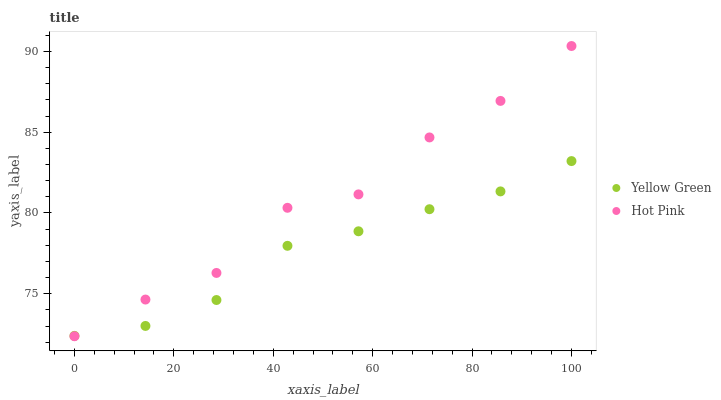Does Yellow Green have the minimum area under the curve?
Answer yes or no. Yes. Does Hot Pink have the maximum area under the curve?
Answer yes or no. Yes. Does Yellow Green have the maximum area under the curve?
Answer yes or no. No. Is Yellow Green the smoothest?
Answer yes or no. Yes. Is Hot Pink the roughest?
Answer yes or no. Yes. Is Yellow Green the roughest?
Answer yes or no. No. Does Hot Pink have the lowest value?
Answer yes or no. Yes. Does Yellow Green have the lowest value?
Answer yes or no. No. Does Hot Pink have the highest value?
Answer yes or no. Yes. Does Yellow Green have the highest value?
Answer yes or no. No. Does Hot Pink intersect Yellow Green?
Answer yes or no. Yes. Is Hot Pink less than Yellow Green?
Answer yes or no. No. Is Hot Pink greater than Yellow Green?
Answer yes or no. No. 